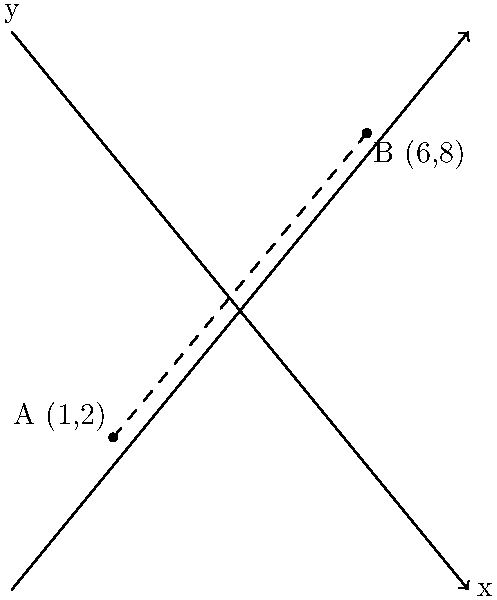As the organizer of a community-based literary festival, you need to calculate the distance between two venues. Venue A is located at coordinates (1,2) and Venue B is at (6,8) on the city map. Using the distance formula, determine the straight-line distance between these two venues. Round your answer to two decimal places. To solve this problem, we'll use the distance formula derived from the Pythagorean theorem:

$$d = \sqrt{(x_2 - x_1)^2 + (y_2 - y_1)^2}$$

Where $(x_1, y_1)$ are the coordinates of point A and $(x_2, y_2)$ are the coordinates of point B.

Step 1: Identify the coordinates
A (1,2) and B (6,8)
$(x_1, y_1) = (1, 2)$
$(x_2, y_2) = (6, 8)$

Step 2: Plug the values into the distance formula
$$d = \sqrt{(6 - 1)^2 + (8 - 2)^2}$$

Step 3: Simplify the expressions inside the parentheses
$$d = \sqrt{(5)^2 + (6)^2}$$

Step 4: Calculate the squares
$$d = \sqrt{25 + 36}$$

Step 5: Add the values under the square root
$$d = \sqrt{61}$$

Step 6: Calculate the square root and round to two decimal places
$$d \approx 7.81$$

Therefore, the straight-line distance between Venue A and Venue B is approximately 7.81 units on the city map.
Answer: 7.81 units 